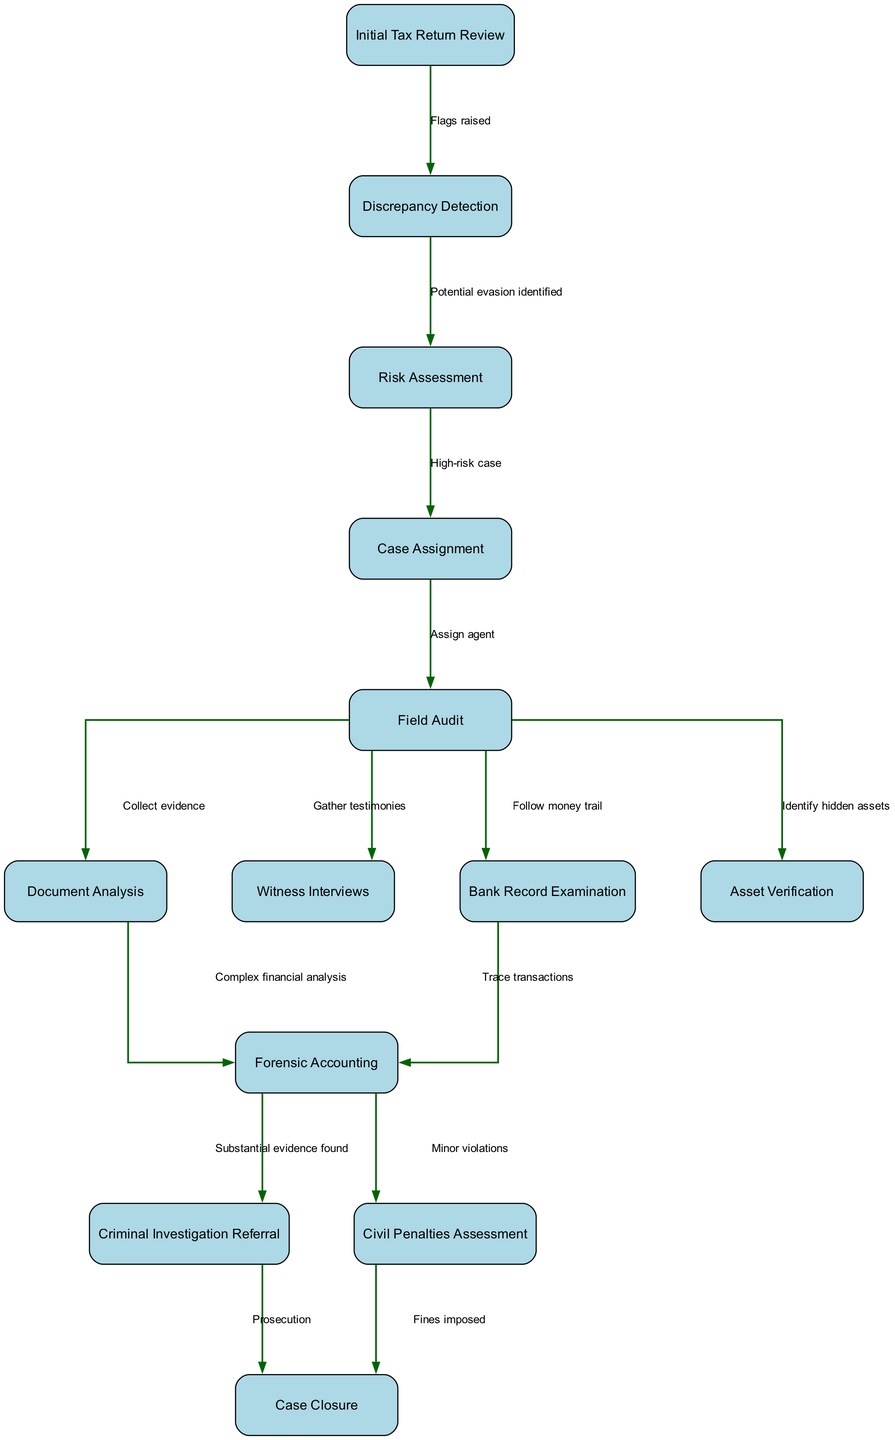What is the first step in the tax evasion detection process? The diagram starts with the "Initial Tax Return Review" as the first step of the process.
Answer: Initial Tax Return Review How many nodes are present in the diagram? The diagram lists a total of 13 unique nodes, each representing a step in the tax evasion detection process.
Answer: 13 What label describes the connection between "Discrepancy Detection" and "Risk Assessment"? The edge connecting "Discrepancy Detection" to "Risk Assessment" is labeled "Potential evasion identified," indicating the reason for this progression.
Answer: Potential evasion identified What happens to cases determined to be high risk? High-risk cases proceed to "Case Assignment," where they are distributed for further action, typically involving audits or investigations.
Answer: Case Assignment Which step follows "Forensic Accounting" if substantial evidence is found? If substantial evidence is identified during "Forensic Accounting," the next step will be a "Criminal Investigation Referral" to push forward legal action.
Answer: Criminal Investigation Referral How many paths lead from "Field Audit"? Four distinct paths emerge from "Field Audit," directing to "Document Analysis," "Witness Interviews," "Bank Record Examination," and "Asset Verification," showcasing various investigative methods utilized.
Answer: 4 What is the final step if fines are imposed? The process concludes at "Case Closure" following "Civil Penalties Assessment," indicating the resolution of the case due to imposed fines.
Answer: Case Closure Which investigative branch is linked to tracing financial transactions? "Bank Record Examination" is explicitly linked to tracing transactions, showing the focus on financial trails as part of the audit process.
Answer: Bank Record Examination What is the last action taken after a criminal investigation referral? After a "Criminal Investigation Referral," the case's last action is recorded as "Case Closure," which signifies the completion of the investigation.
Answer: Case Closure 